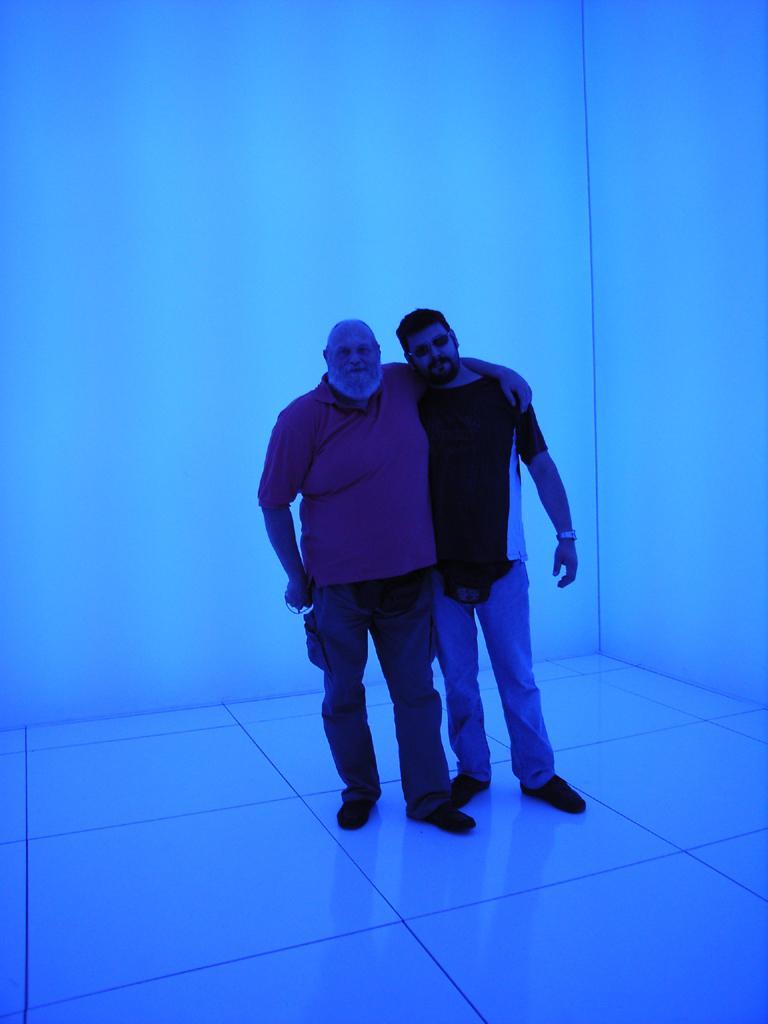How would you summarize this image in a sentence or two? There are two men standing on the floor as we can see in the middle of this image. We can see a wall in the background. 